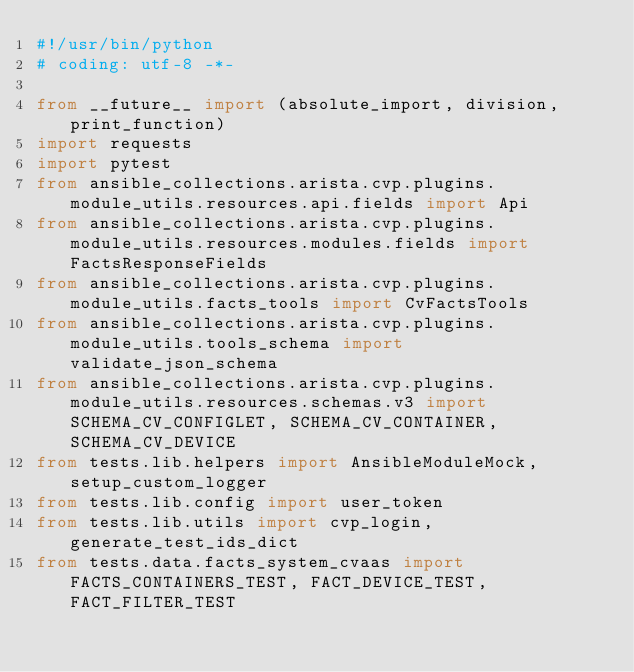<code> <loc_0><loc_0><loc_500><loc_500><_Python_>#!/usr/bin/python
# coding: utf-8 -*-

from __future__ import (absolute_import, division, print_function)
import requests
import pytest
from ansible_collections.arista.cvp.plugins.module_utils.resources.api.fields import Api
from ansible_collections.arista.cvp.plugins.module_utils.resources.modules.fields import FactsResponseFields
from ansible_collections.arista.cvp.plugins.module_utils.facts_tools import CvFactsTools
from ansible_collections.arista.cvp.plugins.module_utils.tools_schema import validate_json_schema
from ansible_collections.arista.cvp.plugins.module_utils.resources.schemas.v3 import SCHEMA_CV_CONFIGLET, SCHEMA_CV_CONTAINER, SCHEMA_CV_DEVICE
from tests.lib.helpers import AnsibleModuleMock, setup_custom_logger
from tests.lib.config import user_token
from tests.lib.utils import cvp_login, generate_test_ids_dict
from tests.data.facts_system_cvaas import FACTS_CONTAINERS_TEST, FACT_DEVICE_TEST, FACT_FILTER_TEST

</code> 